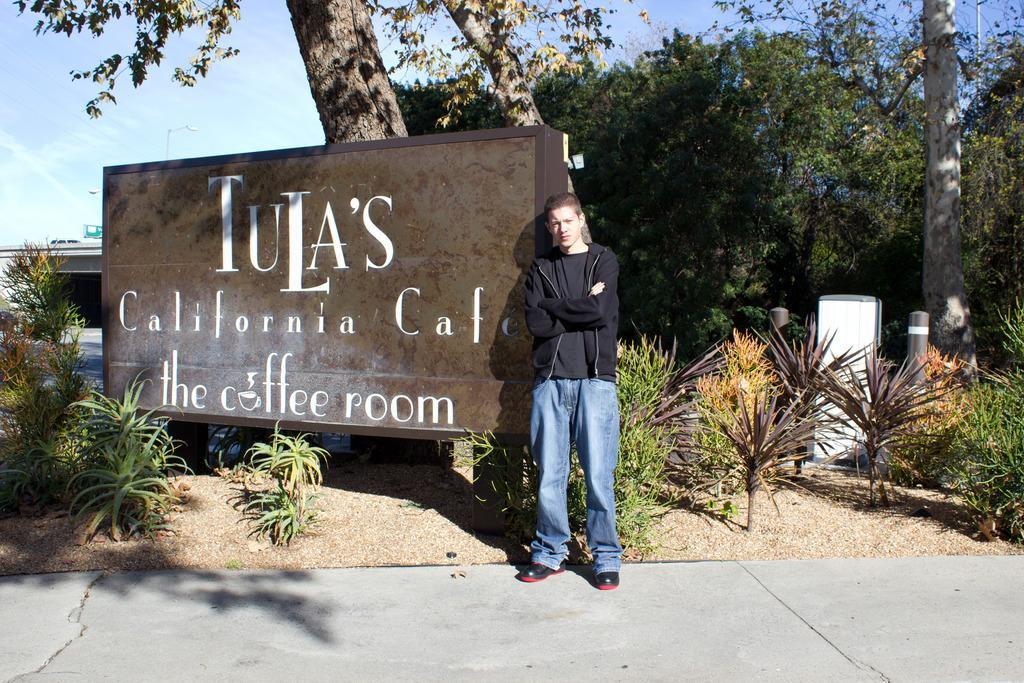Describe this image in one or two sentences. In this picture there is a person wearing black dress is standing beside an object which has something written on it and there are few plants and trees in the background and there is a bridge in the left corner. 